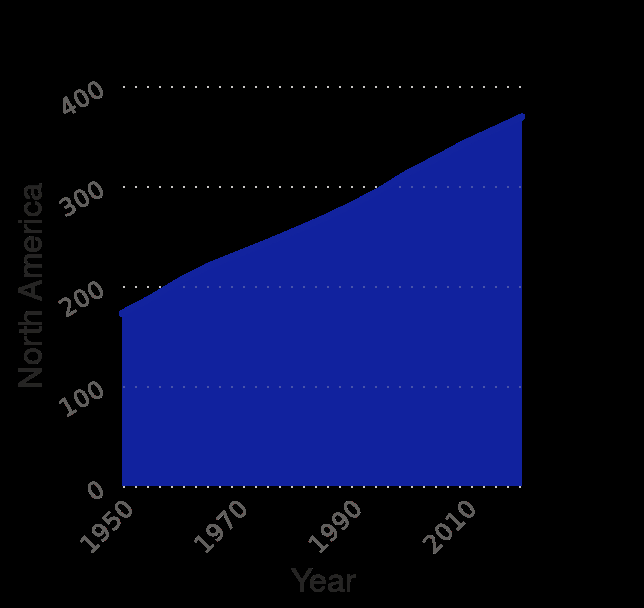<image>
What is the range for measuring North America's population along the y-axis? The range for measuring North America's population along the y-axis is 0 to 400 million. please enumerates aspects of the construction of the chart Population of the world 's continents from 1950 to 2020 (in millions) is a area graph. North America is measured along a linear scale of range 0 to 400 along the y-axis. The x-axis measures Year. please summary the statistics and relations of the chart There is a linear positive relationship between the progressive years and the population of North America. As the years go on, the population of North America steadily increases. 